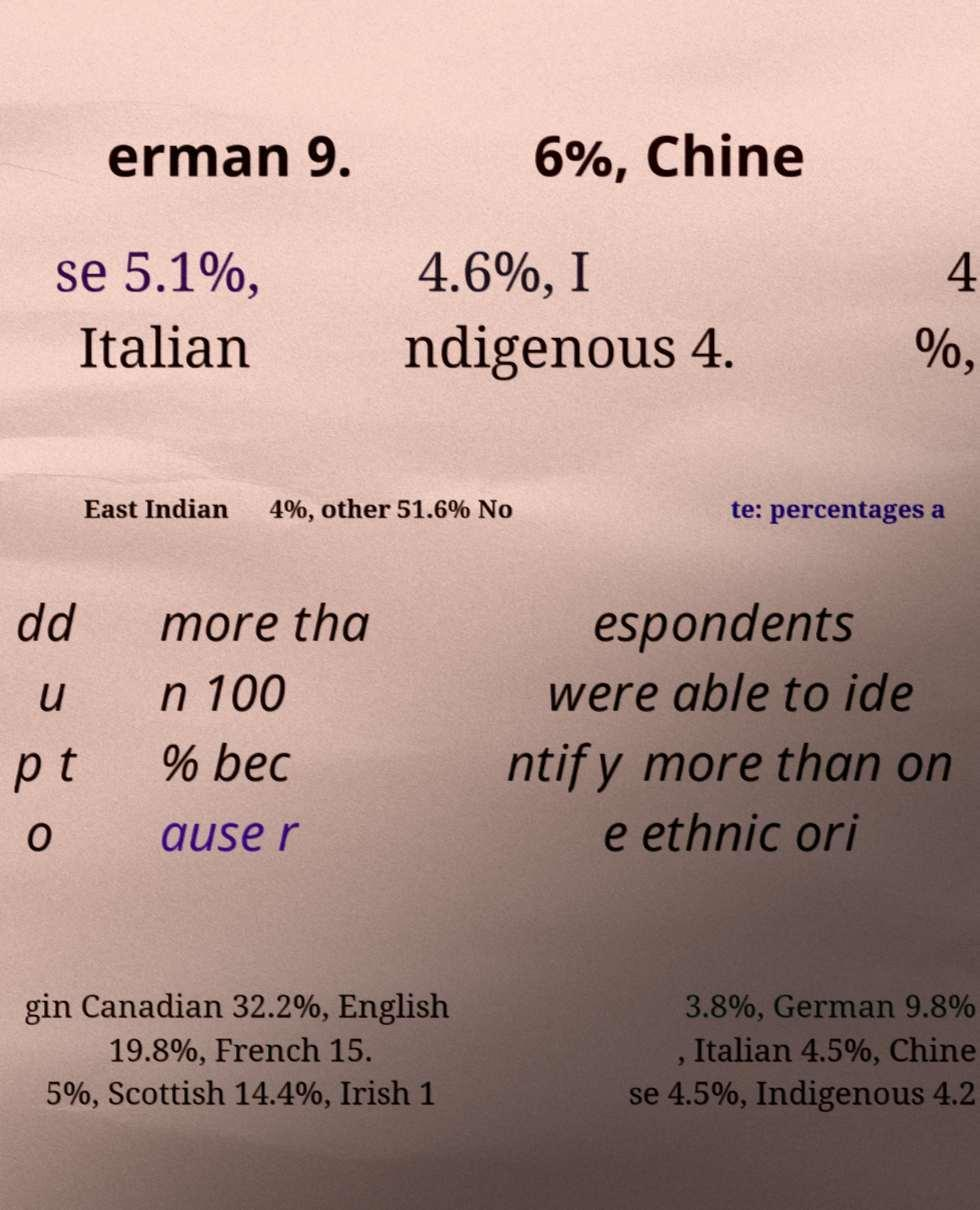For documentation purposes, I need the text within this image transcribed. Could you provide that? erman 9. 6%, Chine se 5.1%, Italian 4.6%, I ndigenous 4. 4 %, East Indian 4%, other 51.6% No te: percentages a dd u p t o more tha n 100 % bec ause r espondents were able to ide ntify more than on e ethnic ori gin Canadian 32.2%, English 19.8%, French 15. 5%, Scottish 14.4%, Irish 1 3.8%, German 9.8% , Italian 4.5%, Chine se 4.5%, Indigenous 4.2 